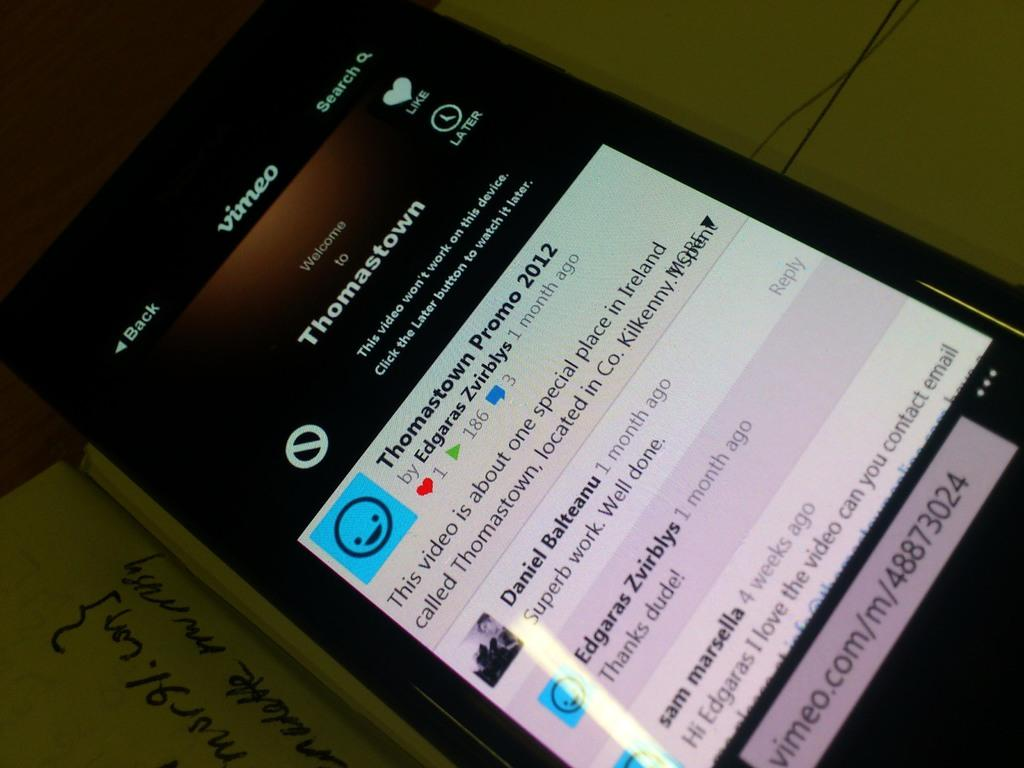<image>
Summarize the visual content of the image. A phone screen is open to the vimeo app, showing information about Thomastown. 